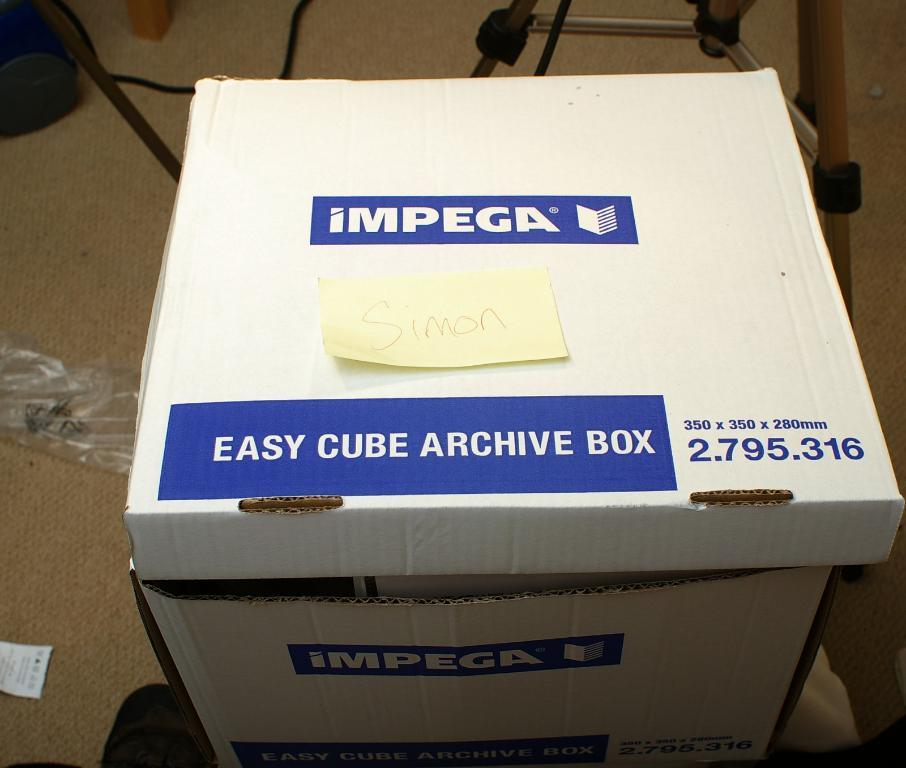<image>
Create a compact narrative representing the image presented. A white and blue box has easy cube archive box on the lid. 